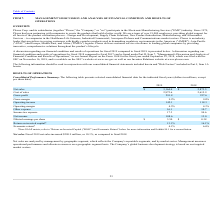According to Plexus's financial document, What was the increase in net sales between 2018 and 2019? According to the financial document, 290.9 (in millions). The relevant text states: "Net sales. Fiscal 2019 net sales increased $290.9 million, or 10.1%, as compared to fiscal 2018...." Also, How was net sales analyzed? by management by geographic segment, which reflects the Company's reportable segments, and by market sector.. The document states: "Net sales are analyzed by management by geographic segment, which reflects the Company's reportable segments, and by market sector. Management measure..." Also, What was the cost of sales in 2018? According to the financial document, 2,615.9 (in thousands). The relevant text states: "Cost of sales 2,872.6 2,615.9..." Also, How many years did the operating margin exceed 4%? Counting the relevant items in the document: 2019, 2018, I find 2 instances. The key data points involved are: 2018, 2019. Also, can you calculate: What was the change in the gross profit between 2018 and 2019? Based on the calculation: 291.8-257.6, the result is 34.2 (in millions). This is based on the information: "Gross profit 291.8 257.6 Gross profit 291.8 257.6..." The key data points involved are: 257.6, 291.8. Also, can you calculate: What was the percentage change in Income tax expense between 2018 and 2019? To answer this question, I need to perform calculations using the financial data. The calculation is: (17.3-94.6)/94.6, which equals -81.71 (percentage). This is based on the information: "Income tax expense 17.3 94.6 Income tax expense 17.3 94.6..." The key data points involved are: 17.3, 94.6. 